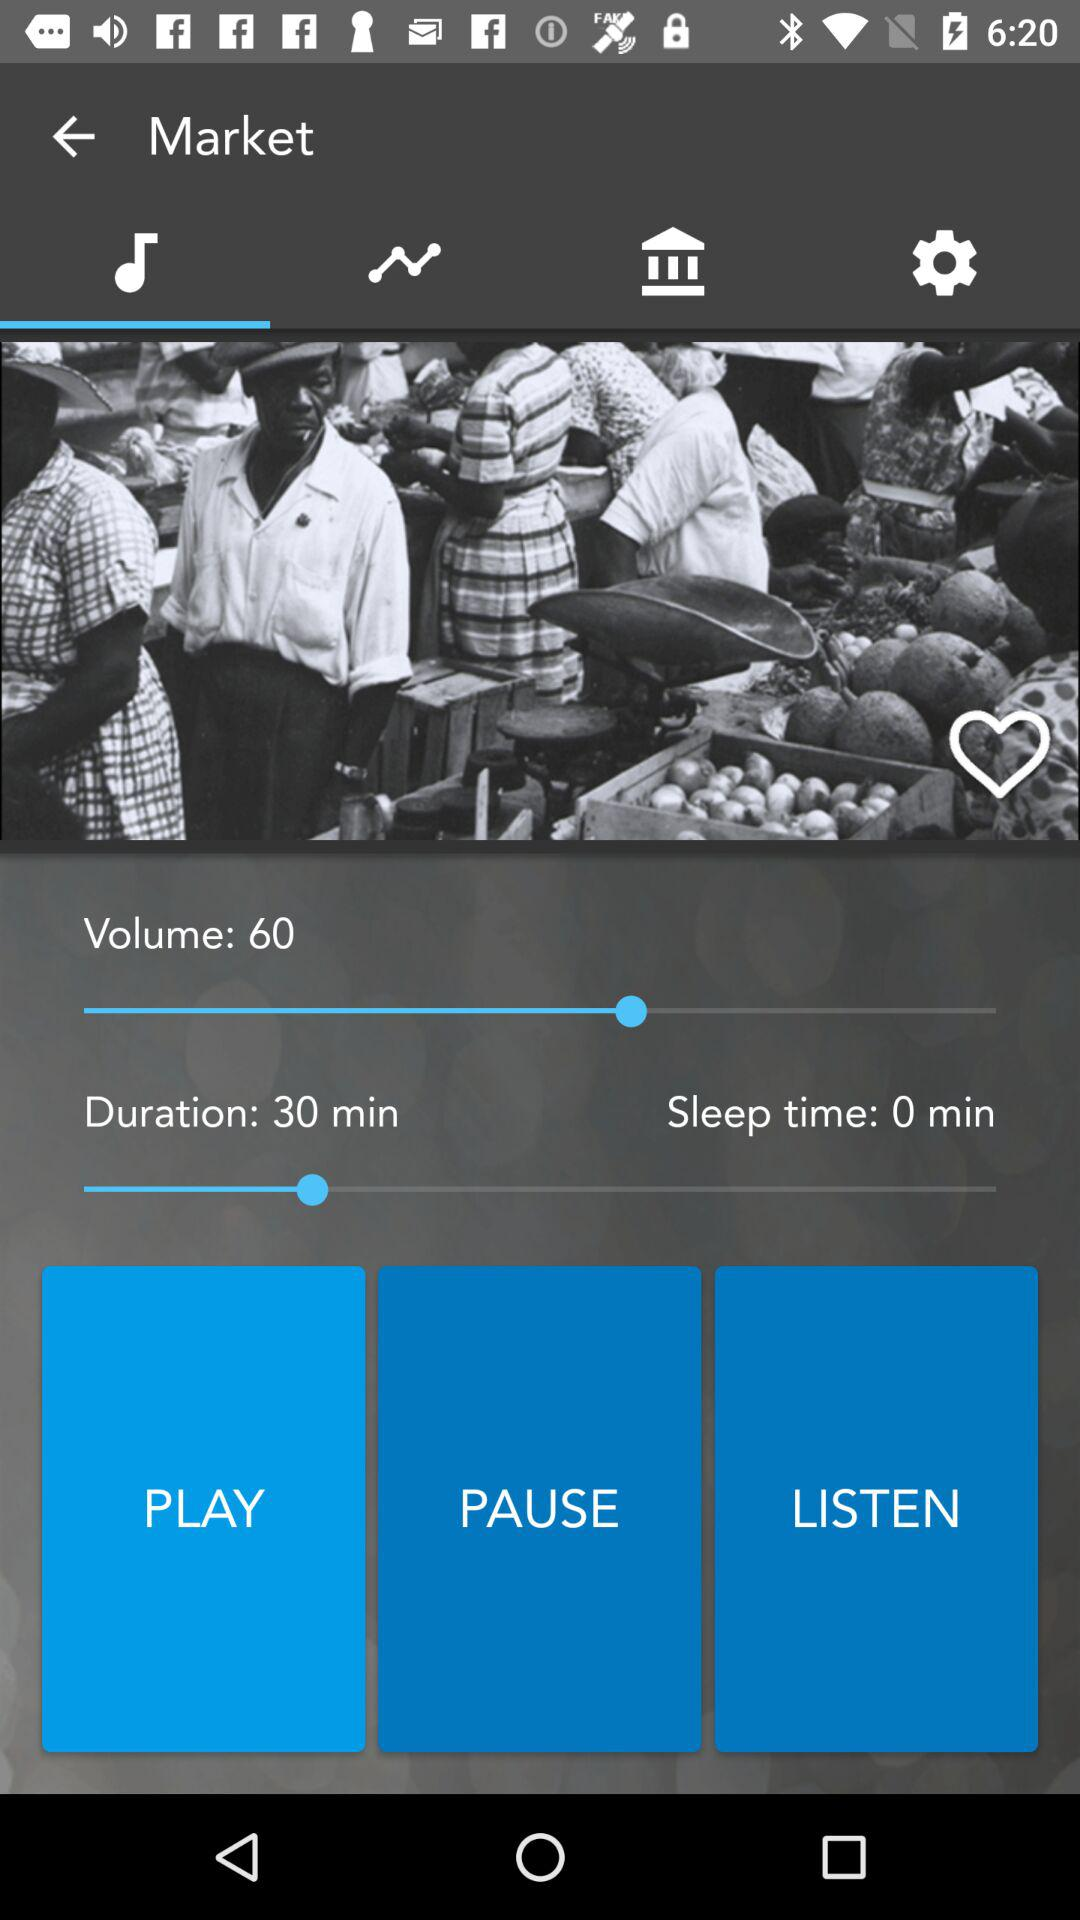Which tab is selected? The selected tab is "Audio". 